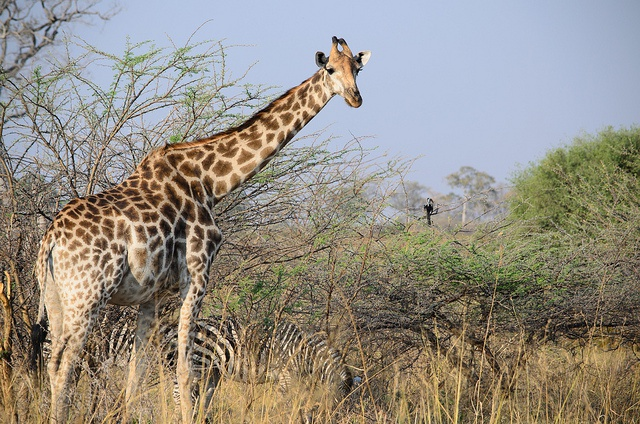Describe the objects in this image and their specific colors. I can see giraffe in gray, tan, and black tones, zebra in gray, tan, and black tones, and bird in gray, black, and darkgray tones in this image. 